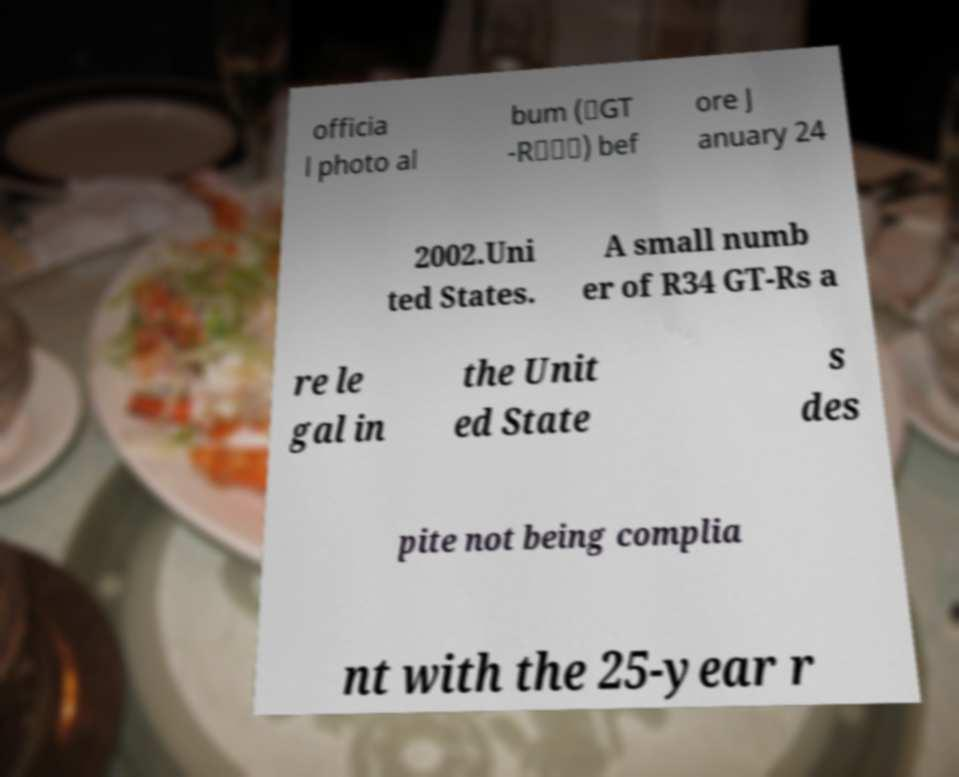I need the written content from this picture converted into text. Can you do that? officia l photo al bum (「GT -R＜＞」) bef ore J anuary 24 2002.Uni ted States. A small numb er of R34 GT-Rs a re le gal in the Unit ed State s des pite not being complia nt with the 25-year r 